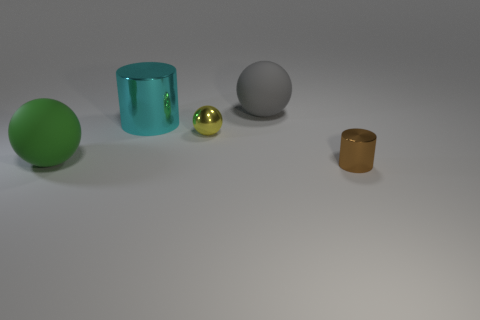What is the size of the matte ball to the left of the big sphere to the right of the large green rubber object?
Offer a very short reply. Large. Is the number of green rubber cylinders less than the number of metallic spheres?
Provide a short and direct response. Yes. There is a object that is in front of the small yellow shiny ball and behind the brown cylinder; what material is it?
Provide a succinct answer. Rubber. There is a large sphere in front of the tiny yellow metal sphere; is there a small cylinder that is behind it?
Provide a short and direct response. No. What number of objects are either large gray things or matte spheres?
Keep it short and to the point. 2. The object that is both right of the metallic sphere and in front of the small yellow object has what shape?
Offer a terse response. Cylinder. Are the tiny thing behind the green ball and the brown cylinder made of the same material?
Give a very brief answer. Yes. What number of objects are either large shiny cylinders or large objects in front of the yellow shiny thing?
Your answer should be very brief. 2. What is the color of the tiny cylinder that is made of the same material as the yellow sphere?
Make the answer very short. Brown. How many other yellow balls have the same material as the yellow sphere?
Provide a succinct answer. 0. 